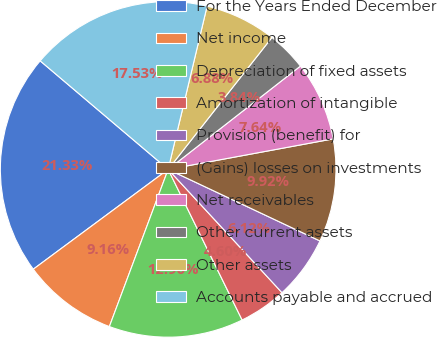<chart> <loc_0><loc_0><loc_500><loc_500><pie_chart><fcel>For the Years Ended December<fcel>Net income<fcel>Depreciation of fixed assets<fcel>Amortization of intangible<fcel>Provision (benefit) for<fcel>(Gains) losses on investments<fcel>Net receivables<fcel>Other current assets<fcel>Other assets<fcel>Accounts payable and accrued<nl><fcel>21.33%<fcel>9.16%<fcel>12.96%<fcel>4.6%<fcel>6.12%<fcel>9.92%<fcel>7.64%<fcel>3.84%<fcel>6.88%<fcel>17.53%<nl></chart> 